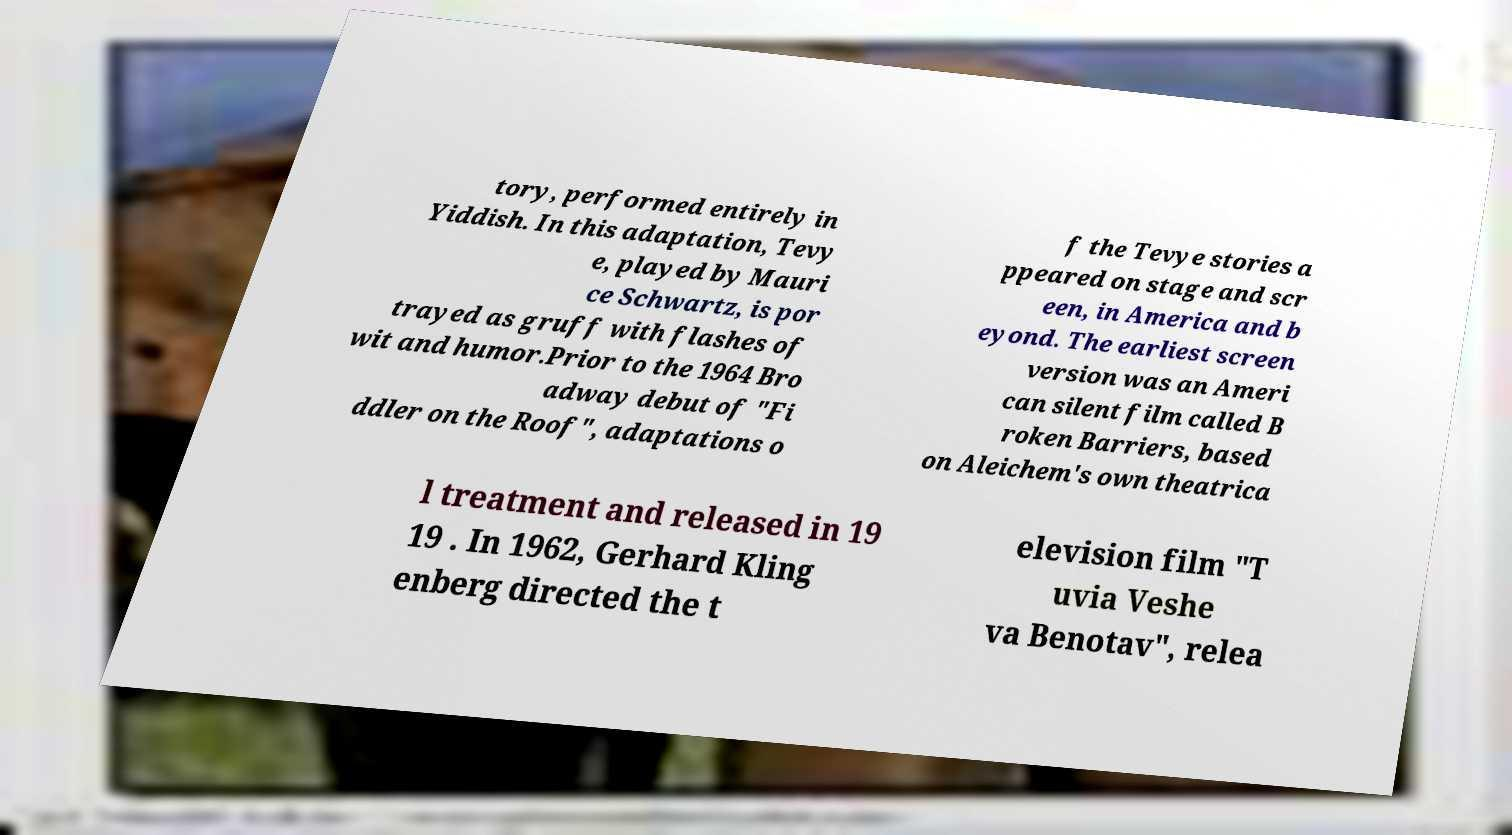For documentation purposes, I need the text within this image transcribed. Could you provide that? tory, performed entirely in Yiddish. In this adaptation, Tevy e, played by Mauri ce Schwartz, is por trayed as gruff with flashes of wit and humor.Prior to the 1964 Bro adway debut of "Fi ddler on the Roof", adaptations o f the Tevye stories a ppeared on stage and scr een, in America and b eyond. The earliest screen version was an Ameri can silent film called B roken Barriers, based on Aleichem's own theatrica l treatment and released in 19 19 . In 1962, Gerhard Kling enberg directed the t elevision film "T uvia Veshe va Benotav", relea 